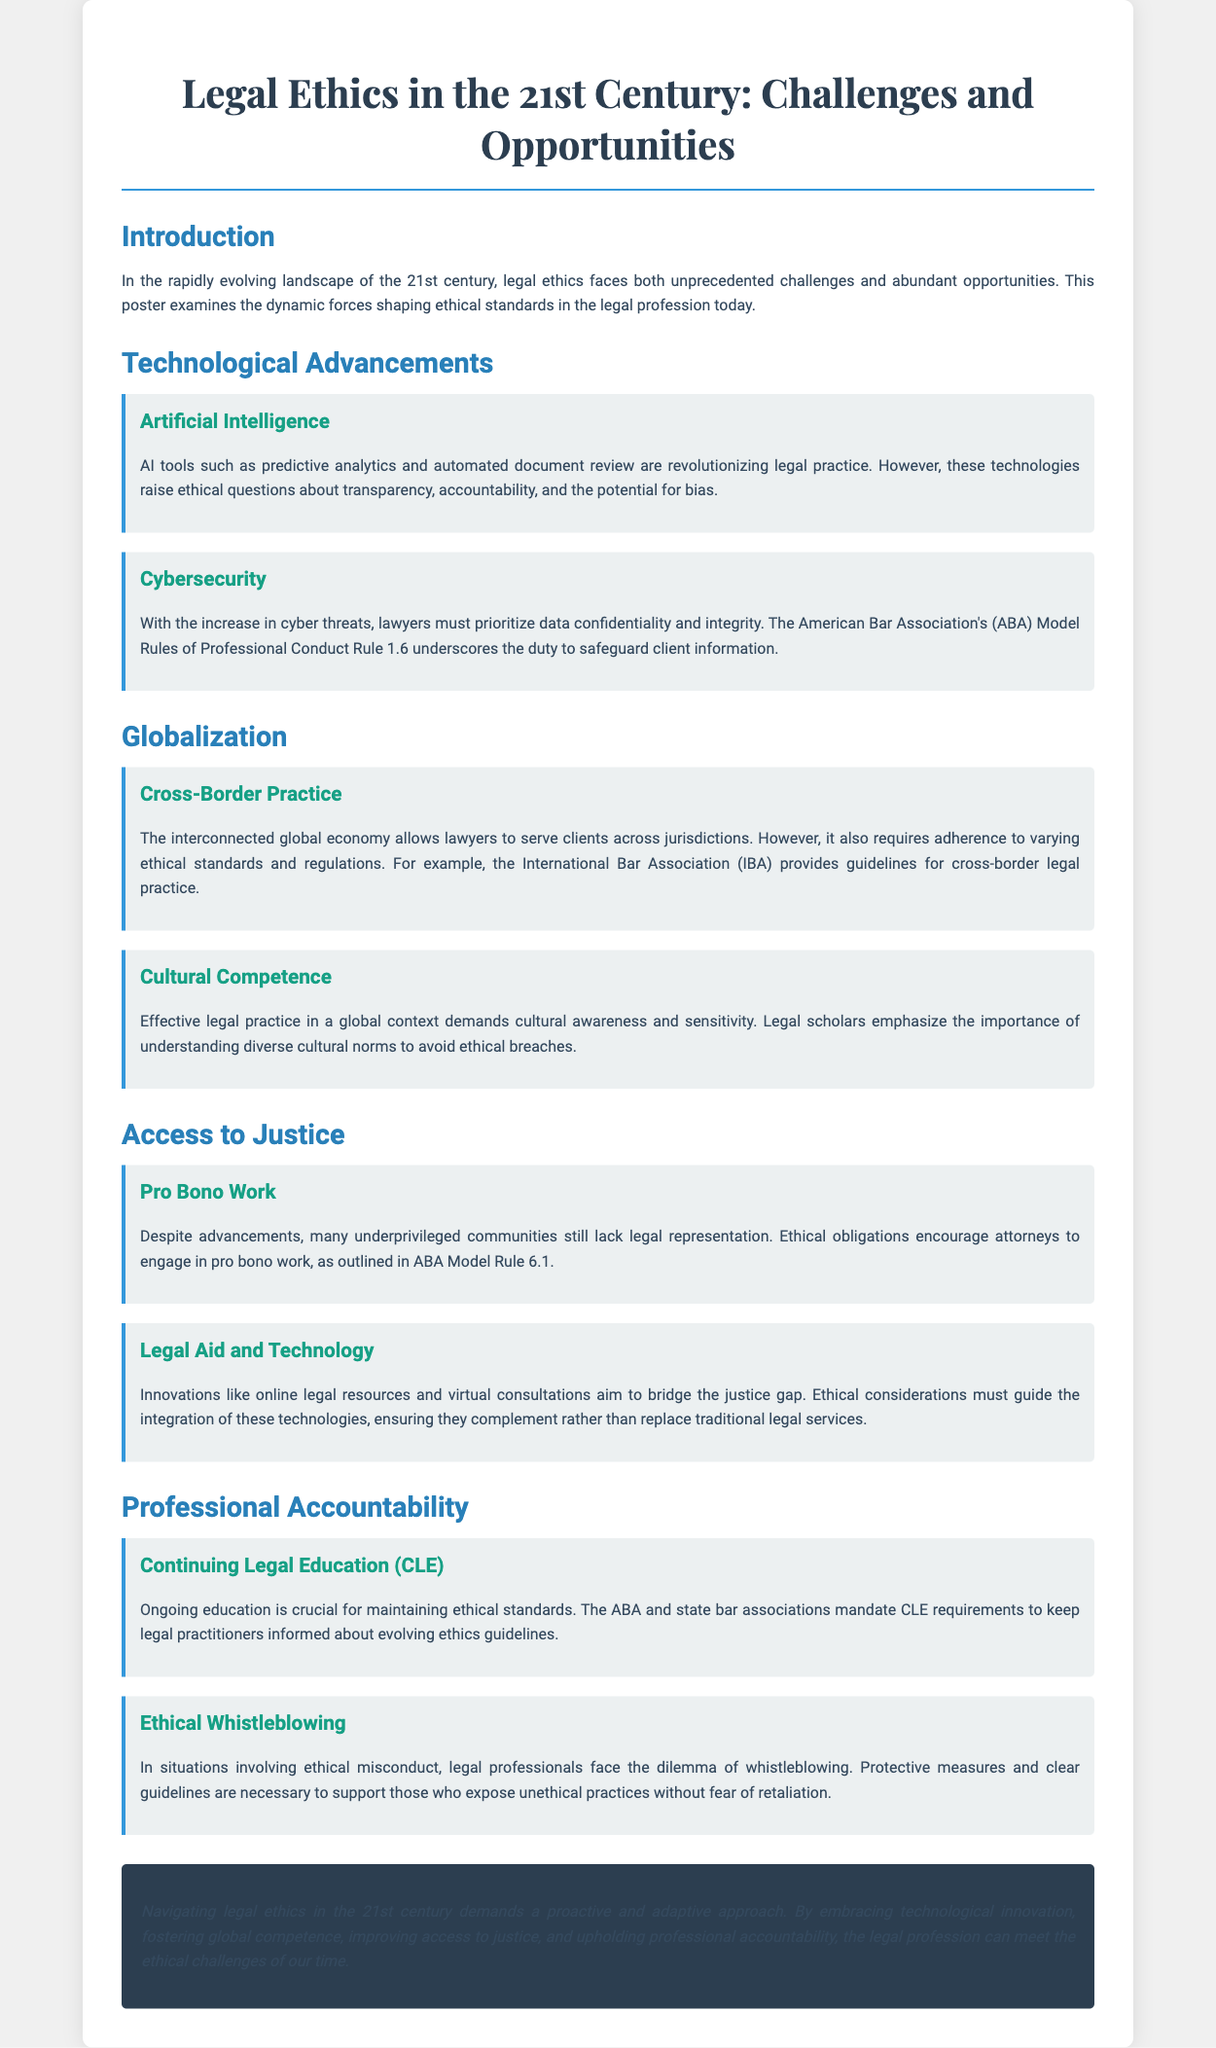What is the title of the poster? The title is the main heading of the document, presented at the top.
Answer: Legal Ethics in the 21st Century: Challenges and Opportunities What ethical principle is highlighted in ABA Model Rule 1.6? This rule underscores the ethical duty regarding client information as mentioned in the section on Cybersecurity.
Answer: Safeguard client information What organization provides guidelines for cross-border legal practice? The document mentions this organization in the context of globalization and ethical standards.
Answer: International Bar Association (IBA) What is a key ethical obligation encouraged for attorneys in relation to underprivileged communities? This is discussed in the section addressing Access to Justice and refers to the ethical duty towards legal representation.
Answer: Pro bono work What does CLE stand for? This abbreviation appears in the section about Professional Accountability and continuing education requirements.
Answer: Continuing Legal Education What is a challenge that lawyers face with AI tools? This question pertains to the implications raised in the Technological Advancements section, discussing ethical concerns.
Answer: Bias What is necessary for supporting ethical whistleblowing? This concept is explored in the subsection regarding Professional Accountability in relation to ethical misconduct.
Answer: Protective measures What type of approach is necessary for navigating legal ethics in the 21st century? The conclusion summarizes the overall perspective of the poster regarding the necessary methods for ethical navigation.
Answer: Proactive and adaptive approach 